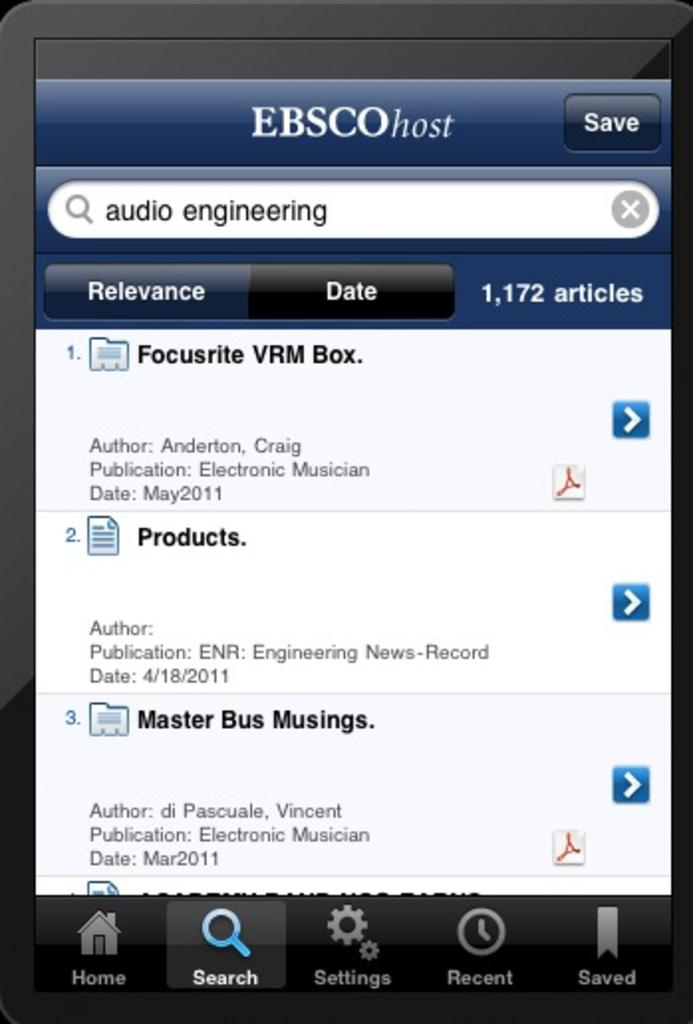<image>
Relay a brief, clear account of the picture shown. a close up of a cell phone screen for EBSCO Host 